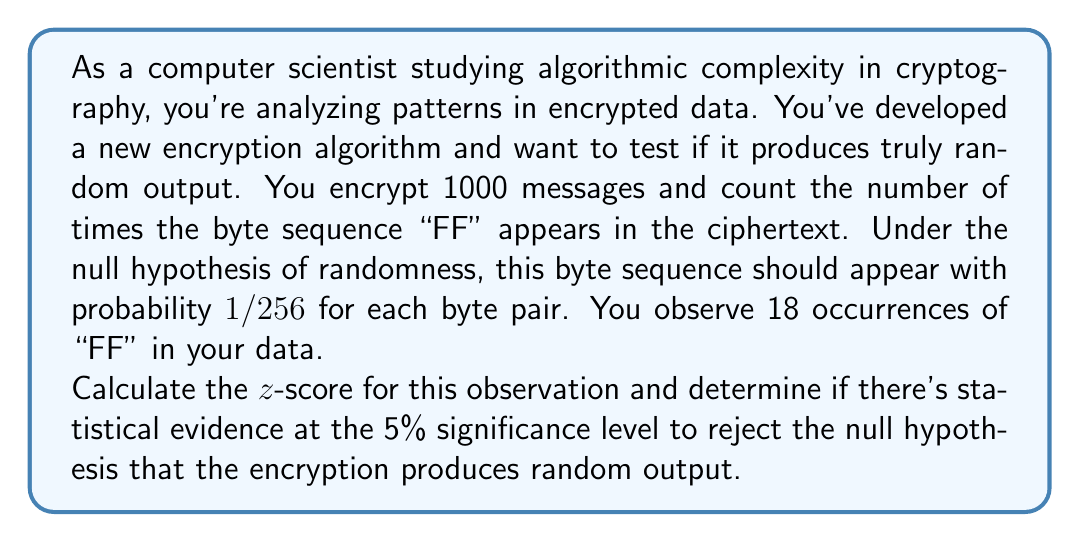Give your solution to this math problem. To solve this problem, we'll follow these steps:

1) First, let's calculate the expected number of "FF" occurrences under the null hypothesis:
   
   $$E = n \cdot p = 1000 \cdot \frac{1}{256} \approx 3.90625$$

   Where n is the number of byte pairs (1000) and p is the probability of "FF" occurring (1/256).

2) Next, we'll calculate the standard deviation:
   
   $$\sigma = \sqrt{n \cdot p \cdot (1-p)} = \sqrt{1000 \cdot \frac{1}{256} \cdot \frac{255}{256}} \approx 1.9638$$

3) Now we can calculate the z-score:
   
   $$z = \frac{X - E}{\sigma} = \frac{18 - 3.90625}{1.9638} \approx 7.1775$$

   Where X is the observed number of occurrences (18).

4) To determine statistical significance at the 5% level, we compare this to the critical z-value for a two-tailed test, which is approximately 1.96.

5) Since our calculated z-score (7.1775) is greater than 1.96, we reject the null hypothesis.

This means there is strong statistical evidence to suggest that the encryption algorithm is not producing truly random output, as the occurrence of "FF" is significantly higher than expected under randomness.
Answer: The z-score is approximately 7.1775. At the 5% significance level, we reject the null hypothesis, providing strong evidence that the encryption algorithm is not producing truly random output. 